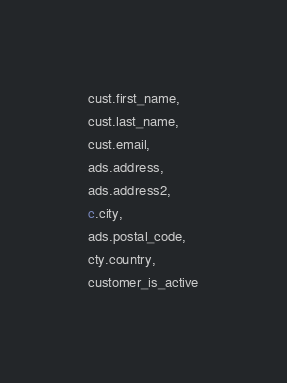Convert code to text. <code><loc_0><loc_0><loc_500><loc_500><_SQL_>cust.first_name,
cust.last_name,
cust.email,
ads.address,
ads.address2,
c.city,
ads.postal_code,
cty.country, 
customer_is_active</code> 